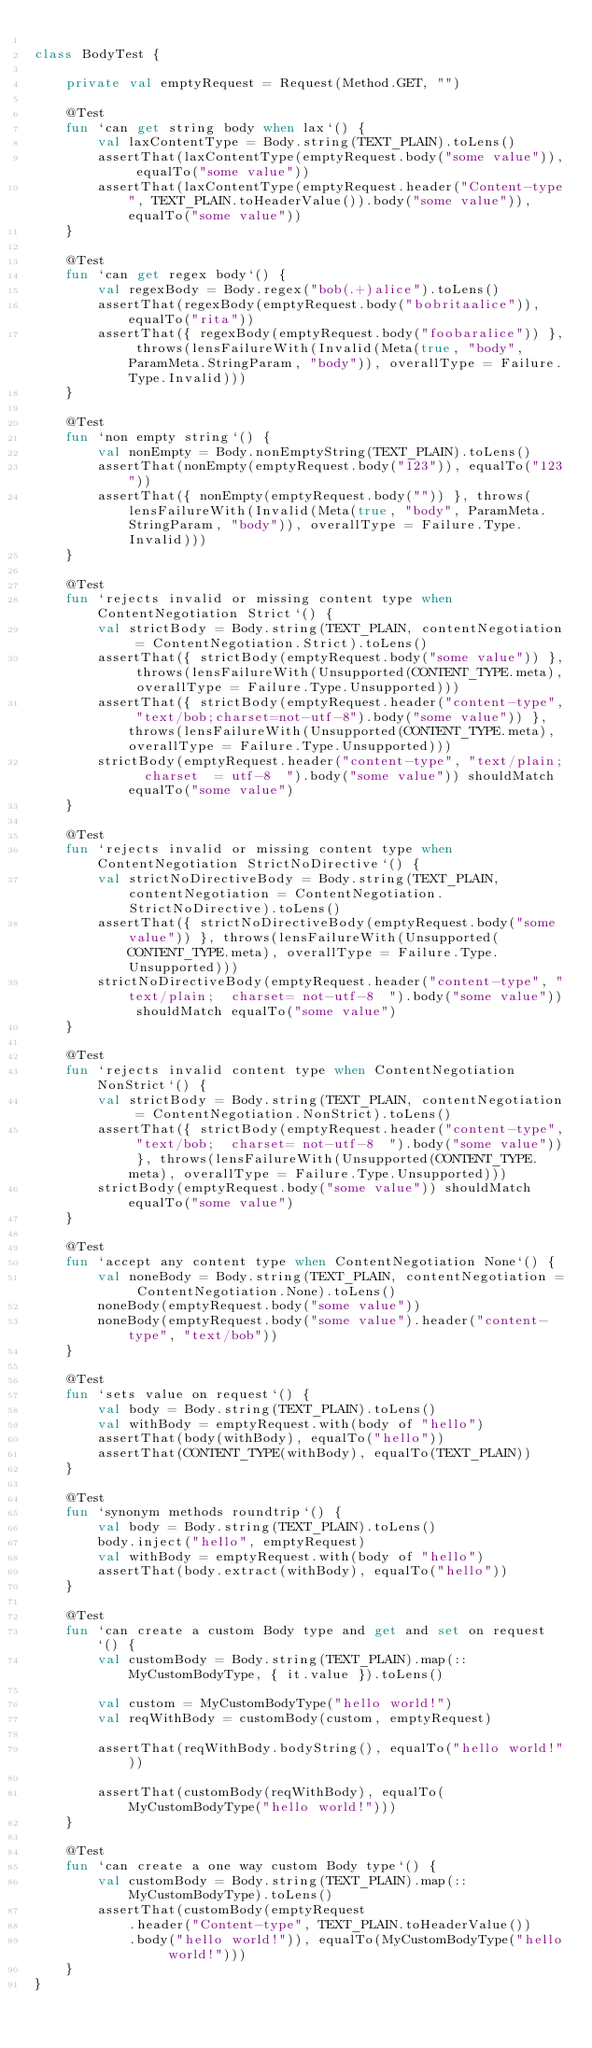Convert code to text. <code><loc_0><loc_0><loc_500><loc_500><_Kotlin_>
class BodyTest {

    private val emptyRequest = Request(Method.GET, "")

    @Test
    fun `can get string body when lax`() {
        val laxContentType = Body.string(TEXT_PLAIN).toLens()
        assertThat(laxContentType(emptyRequest.body("some value")), equalTo("some value"))
        assertThat(laxContentType(emptyRequest.header("Content-type", TEXT_PLAIN.toHeaderValue()).body("some value")), equalTo("some value"))
    }

    @Test
    fun `can get regex body`() {
        val regexBody = Body.regex("bob(.+)alice").toLens()
        assertThat(regexBody(emptyRequest.body("bobritaalice")), equalTo("rita"))
        assertThat({ regexBody(emptyRequest.body("foobaralice")) }, throws(lensFailureWith(Invalid(Meta(true, "body", ParamMeta.StringParam, "body")), overallType = Failure.Type.Invalid)))
    }

    @Test
    fun `non empty string`() {
        val nonEmpty = Body.nonEmptyString(TEXT_PLAIN).toLens()
        assertThat(nonEmpty(emptyRequest.body("123")), equalTo("123"))
        assertThat({ nonEmpty(emptyRequest.body("")) }, throws(lensFailureWith(Invalid(Meta(true, "body", ParamMeta.StringParam, "body")), overallType = Failure.Type.Invalid)))
    }

    @Test
    fun `rejects invalid or missing content type when ContentNegotiation Strict`() {
        val strictBody = Body.string(TEXT_PLAIN, contentNegotiation = ContentNegotiation.Strict).toLens()
        assertThat({ strictBody(emptyRequest.body("some value")) }, throws(lensFailureWith(Unsupported(CONTENT_TYPE.meta), overallType = Failure.Type.Unsupported)))
        assertThat({ strictBody(emptyRequest.header("content-type", "text/bob;charset=not-utf-8").body("some value")) }, throws(lensFailureWith(Unsupported(CONTENT_TYPE.meta), overallType = Failure.Type.Unsupported)))
        strictBody(emptyRequest.header("content-type", "text/plain;  charset  = utf-8  ").body("some value")) shouldMatch equalTo("some value")
    }

    @Test
    fun `rejects invalid or missing content type when ContentNegotiation StrictNoDirective`() {
        val strictNoDirectiveBody = Body.string(TEXT_PLAIN, contentNegotiation = ContentNegotiation.StrictNoDirective).toLens()
        assertThat({ strictNoDirectiveBody(emptyRequest.body("some value")) }, throws(lensFailureWith(Unsupported(CONTENT_TYPE.meta), overallType = Failure.Type.Unsupported)))
        strictNoDirectiveBody(emptyRequest.header("content-type", "text/plain;  charset= not-utf-8  ").body("some value")) shouldMatch equalTo("some value")
    }

    @Test
    fun `rejects invalid content type when ContentNegotiation NonStrict`() {
        val strictBody = Body.string(TEXT_PLAIN, contentNegotiation = ContentNegotiation.NonStrict).toLens()
        assertThat({ strictBody(emptyRequest.header("content-type", "text/bob;  charset= not-utf-8  ").body("some value")) }, throws(lensFailureWith(Unsupported(CONTENT_TYPE.meta), overallType = Failure.Type.Unsupported)))
        strictBody(emptyRequest.body("some value")) shouldMatch equalTo("some value")
    }

    @Test
    fun `accept any content type when ContentNegotiation None`() {
        val noneBody = Body.string(TEXT_PLAIN, contentNegotiation = ContentNegotiation.None).toLens()
        noneBody(emptyRequest.body("some value"))
        noneBody(emptyRequest.body("some value").header("content-type", "text/bob"))
    }

    @Test
    fun `sets value on request`() {
        val body = Body.string(TEXT_PLAIN).toLens()
        val withBody = emptyRequest.with(body of "hello")
        assertThat(body(withBody), equalTo("hello"))
        assertThat(CONTENT_TYPE(withBody), equalTo(TEXT_PLAIN))
    }

    @Test
    fun `synonym methods roundtrip`() {
        val body = Body.string(TEXT_PLAIN).toLens()
        body.inject("hello", emptyRequest)
        val withBody = emptyRequest.with(body of "hello")
        assertThat(body.extract(withBody), equalTo("hello"))
    }

    @Test
    fun `can create a custom Body type and get and set on request`() {
        val customBody = Body.string(TEXT_PLAIN).map(::MyCustomBodyType, { it.value }).toLens()

        val custom = MyCustomBodyType("hello world!")
        val reqWithBody = customBody(custom, emptyRequest)

        assertThat(reqWithBody.bodyString(), equalTo("hello world!"))

        assertThat(customBody(reqWithBody), equalTo(MyCustomBodyType("hello world!")))
    }

    @Test
    fun `can create a one way custom Body type`() {
        val customBody = Body.string(TEXT_PLAIN).map(::MyCustomBodyType).toLens()
        assertThat(customBody(emptyRequest
            .header("Content-type", TEXT_PLAIN.toHeaderValue())
            .body("hello world!")), equalTo(MyCustomBodyType("hello world!")))
    }
}


</code> 